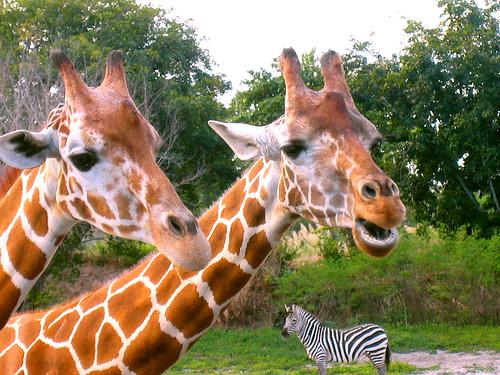What is in front of the zebra? giraffe 